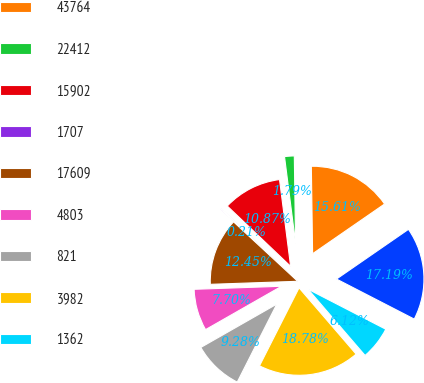Convert chart to OTSL. <chart><loc_0><loc_0><loc_500><loc_500><pie_chart><fcel>66176<fcel>43764<fcel>22412<fcel>15902<fcel>1707<fcel>17609<fcel>4803<fcel>821<fcel>3982<fcel>1362<nl><fcel>17.19%<fcel>15.61%<fcel>1.79%<fcel>10.87%<fcel>0.21%<fcel>12.45%<fcel>7.7%<fcel>9.28%<fcel>18.78%<fcel>6.12%<nl></chart> 